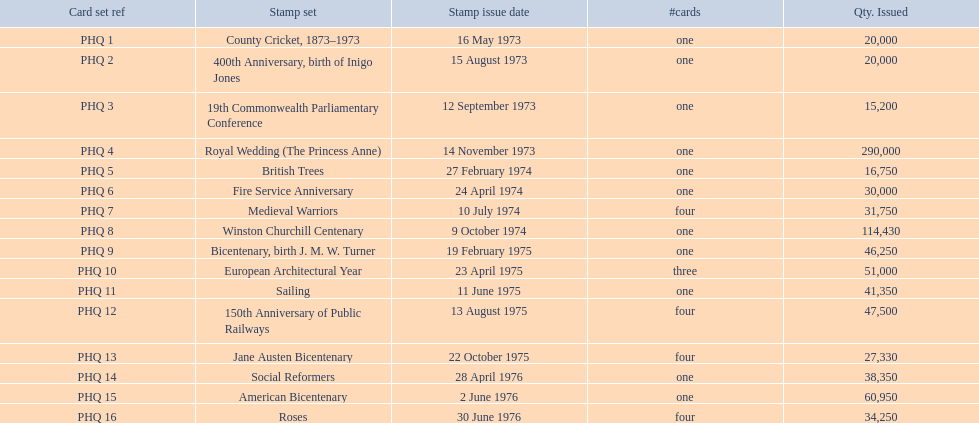What are all the stamp sets? County Cricket, 1873–1973, 400th Anniversary, birth of Inigo Jones, 19th Commonwealth Parliamentary Conference, Royal Wedding (The Princess Anne), British Trees, Fire Service Anniversary, Medieval Warriors, Winston Churchill Centenary, Bicentenary, birth J. M. W. Turner, European Architectural Year, Sailing, 150th Anniversary of Public Railways, Jane Austen Bicentenary, Social Reformers, American Bicentenary, Roses. For these sets, what were the quantities issued? 20,000, 20,000, 15,200, 290,000, 16,750, 30,000, 31,750, 114,430, 46,250, 51,000, 41,350, 47,500, 27,330, 38,350, 60,950, 34,250. Of these, which quantity is above 200,000? 290,000. What is the stamp set corresponding to this quantity? Royal Wedding (The Princess Anne). 